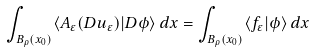Convert formula to latex. <formula><loc_0><loc_0><loc_500><loc_500>\int _ { B _ { \rho } ( x _ { 0 } ) } \langle A _ { \varepsilon } ( D u _ { \varepsilon } ) | D \phi \rangle \, { d } x = \int _ { B _ { \rho } ( x _ { 0 } ) } \langle f _ { \varepsilon } | \phi \rangle \, { d } x</formula> 